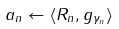Convert formula to latex. <formula><loc_0><loc_0><loc_500><loc_500>a _ { n } \leftarrow \langle R _ { n } , g _ { \gamma _ { n } } \rangle</formula> 